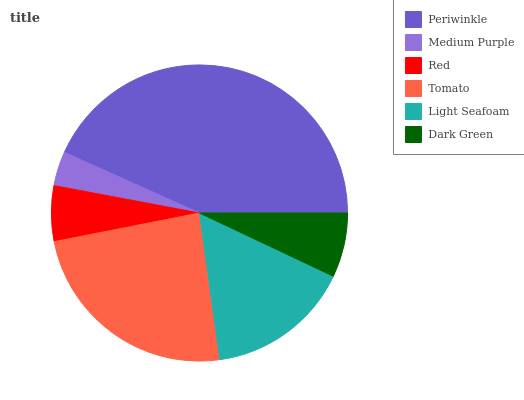Is Medium Purple the minimum?
Answer yes or no. Yes. Is Periwinkle the maximum?
Answer yes or no. Yes. Is Red the minimum?
Answer yes or no. No. Is Red the maximum?
Answer yes or no. No. Is Red greater than Medium Purple?
Answer yes or no. Yes. Is Medium Purple less than Red?
Answer yes or no. Yes. Is Medium Purple greater than Red?
Answer yes or no. No. Is Red less than Medium Purple?
Answer yes or no. No. Is Light Seafoam the high median?
Answer yes or no. Yes. Is Dark Green the low median?
Answer yes or no. Yes. Is Red the high median?
Answer yes or no. No. Is Periwinkle the low median?
Answer yes or no. No. 